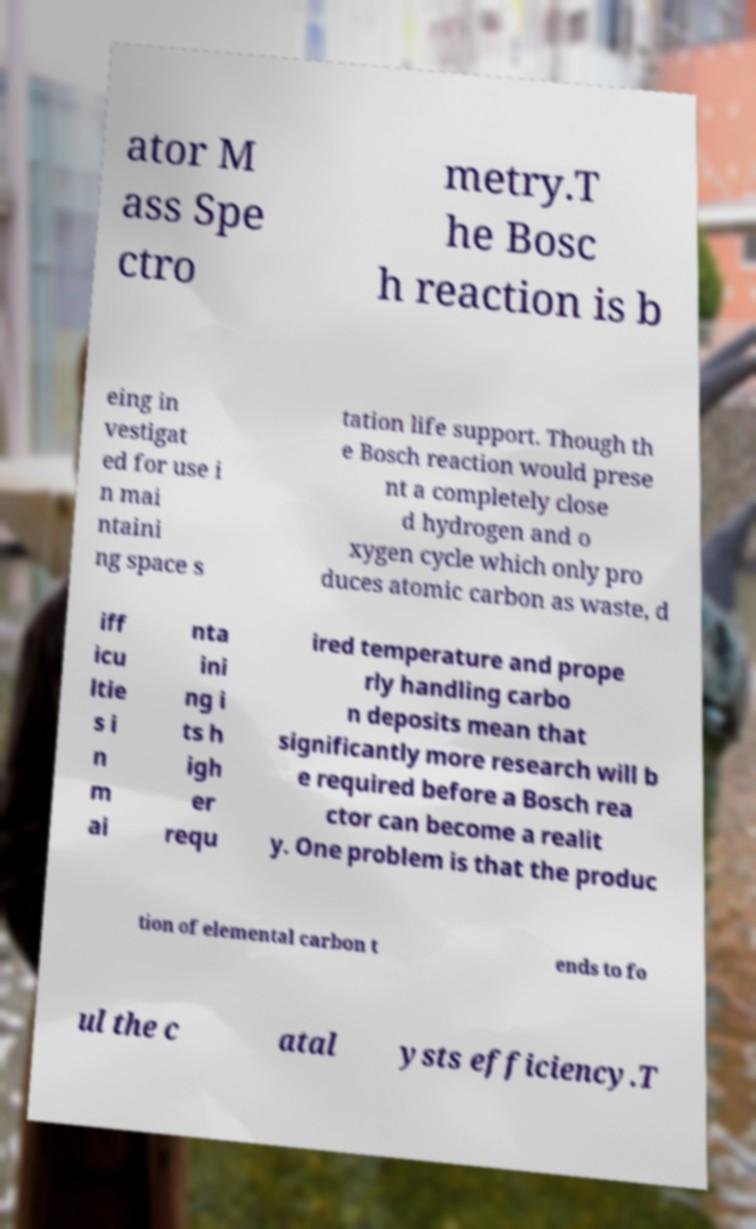Could you extract and type out the text from this image? ator M ass Spe ctro metry.T he Bosc h reaction is b eing in vestigat ed for use i n mai ntaini ng space s tation life support. Though th e Bosch reaction would prese nt a completely close d hydrogen and o xygen cycle which only pro duces atomic carbon as waste, d iff icu ltie s i n m ai nta ini ng i ts h igh er requ ired temperature and prope rly handling carbo n deposits mean that significantly more research will b e required before a Bosch rea ctor can become a realit y. One problem is that the produc tion of elemental carbon t ends to fo ul the c atal ysts efficiency.T 